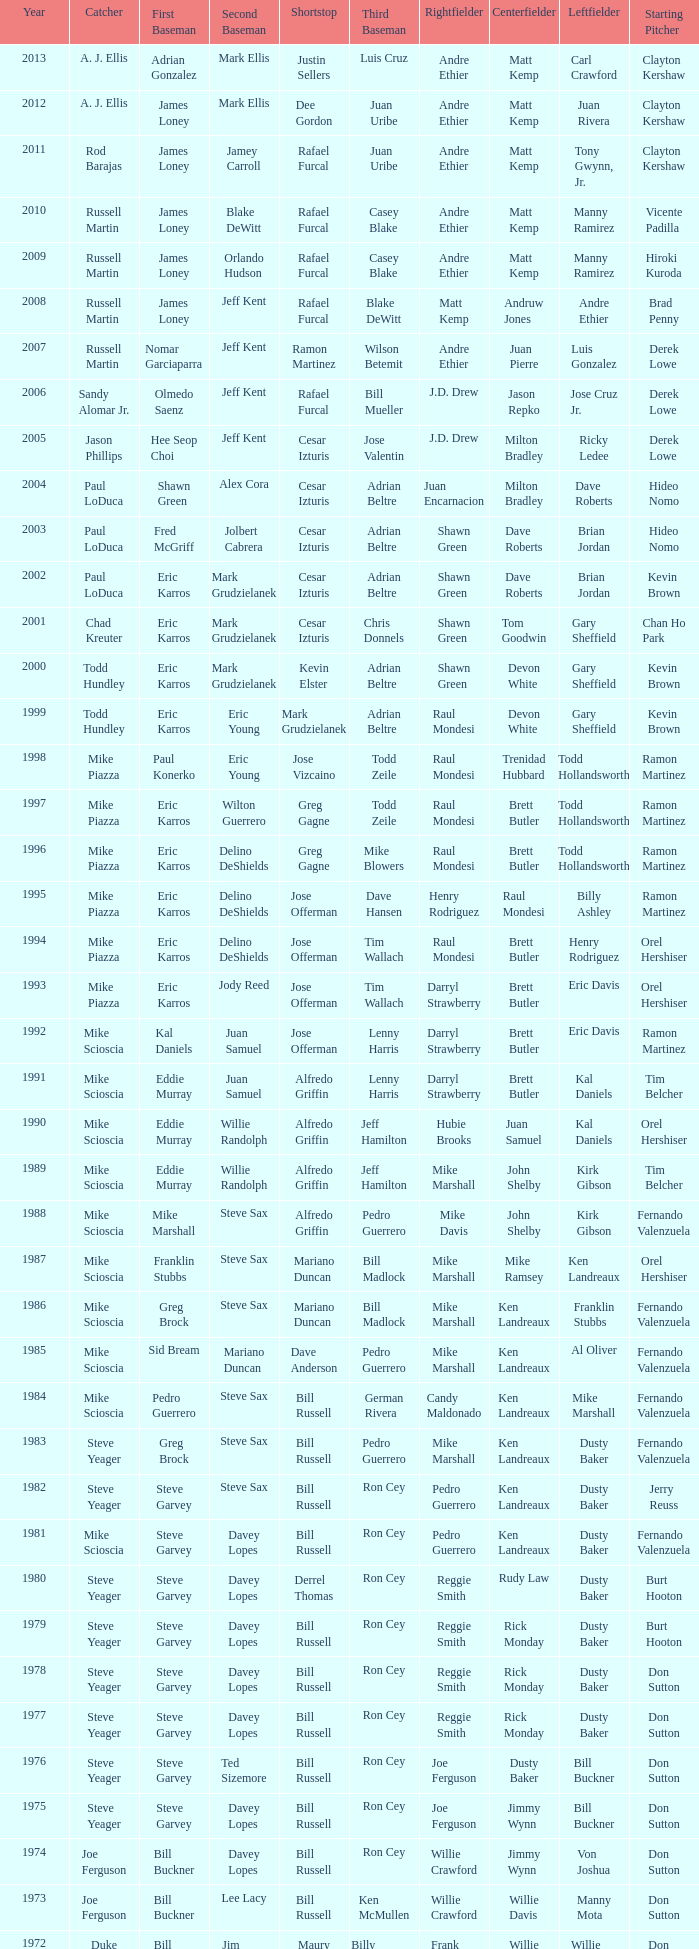Who played SS when paul konerko played 1st base? Jose Vizcaino. 